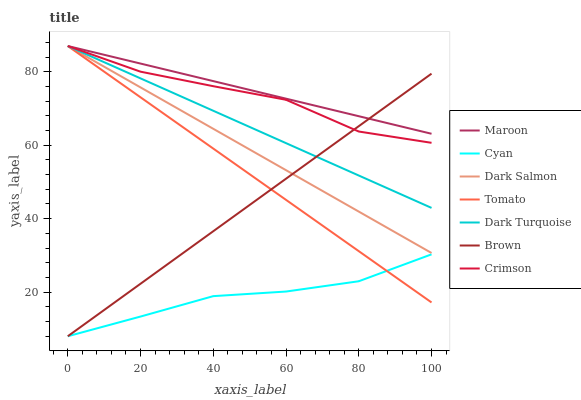Does Cyan have the minimum area under the curve?
Answer yes or no. Yes. Does Maroon have the maximum area under the curve?
Answer yes or no. Yes. Does Brown have the minimum area under the curve?
Answer yes or no. No. Does Brown have the maximum area under the curve?
Answer yes or no. No. Is Maroon the smoothest?
Answer yes or no. Yes. Is Crimson the roughest?
Answer yes or no. Yes. Is Brown the smoothest?
Answer yes or no. No. Is Brown the roughest?
Answer yes or no. No. Does Dark Turquoise have the lowest value?
Answer yes or no. No. Does Crimson have the highest value?
Answer yes or no. Yes. Does Brown have the highest value?
Answer yes or no. No. Is Cyan less than Dark Salmon?
Answer yes or no. Yes. Is Dark Turquoise greater than Cyan?
Answer yes or no. Yes. Does Cyan intersect Dark Salmon?
Answer yes or no. No. 